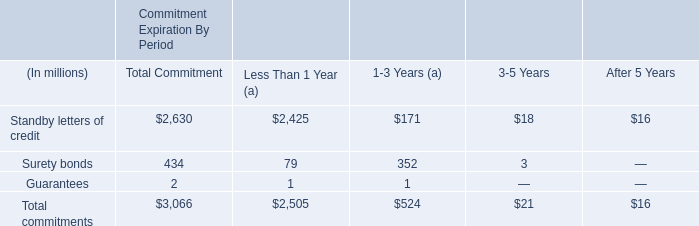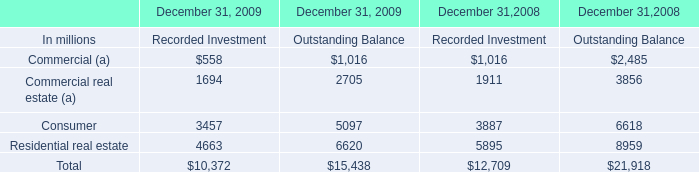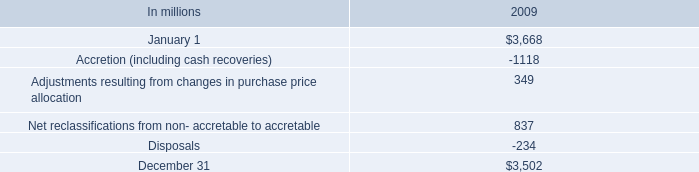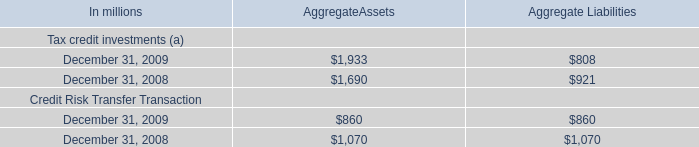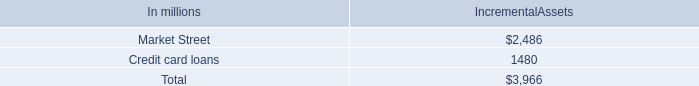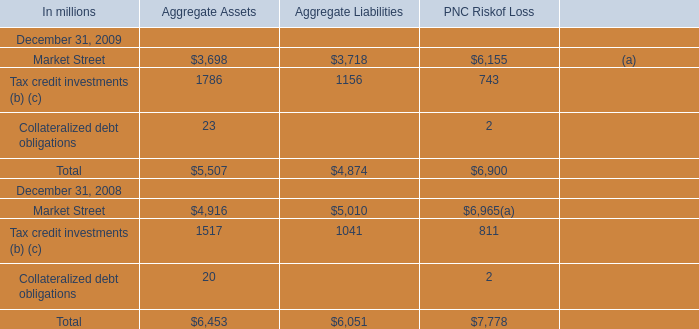What is the sum of the Aggregate Liabilities for Tax credit investments (a) in the years where AggregateAssets is positive AggregateAssets positive for Tax credit investments (a)?? (in million) 
Computations: (808 + 921)
Answer: 1729.0. 